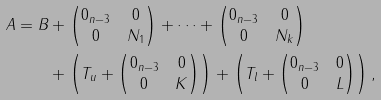Convert formula to latex. <formula><loc_0><loc_0><loc_500><loc_500>A = B & + \begin{pmatrix} 0 _ { n - 3 } & 0 \\ 0 & N _ { 1 } \end{pmatrix} + \dots + \begin{pmatrix} 0 _ { n - 3 } & 0 \\ 0 & N _ { k } \end{pmatrix} \\ & + \left ( T _ { u } + \begin{pmatrix} 0 _ { n - 3 } & 0 \\ 0 & K \end{pmatrix} \right ) + \left ( T _ { l } + \begin{pmatrix} 0 _ { n - 3 } & 0 \\ 0 & L \end{pmatrix} \right ) ,</formula> 